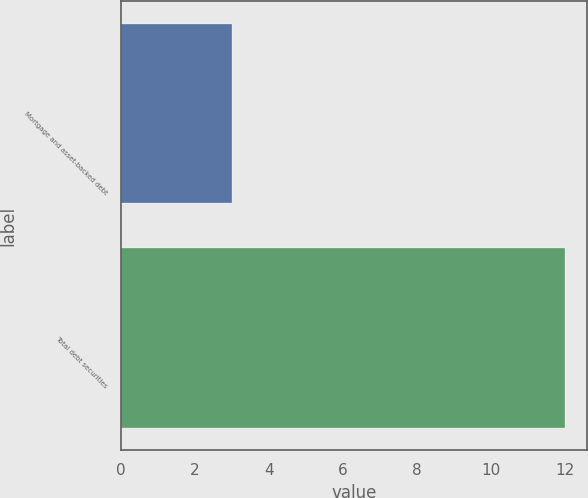Convert chart. <chart><loc_0><loc_0><loc_500><loc_500><bar_chart><fcel>Mortgage and asset-backed debt<fcel>Total debt securities<nl><fcel>3<fcel>12<nl></chart> 